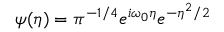<formula> <loc_0><loc_0><loc_500><loc_500>\psi ( \eta ) = \pi ^ { - 1 / 4 } e ^ { i \omega _ { 0 } \eta } e ^ { - \eta ^ { 2 } / 2 }</formula> 